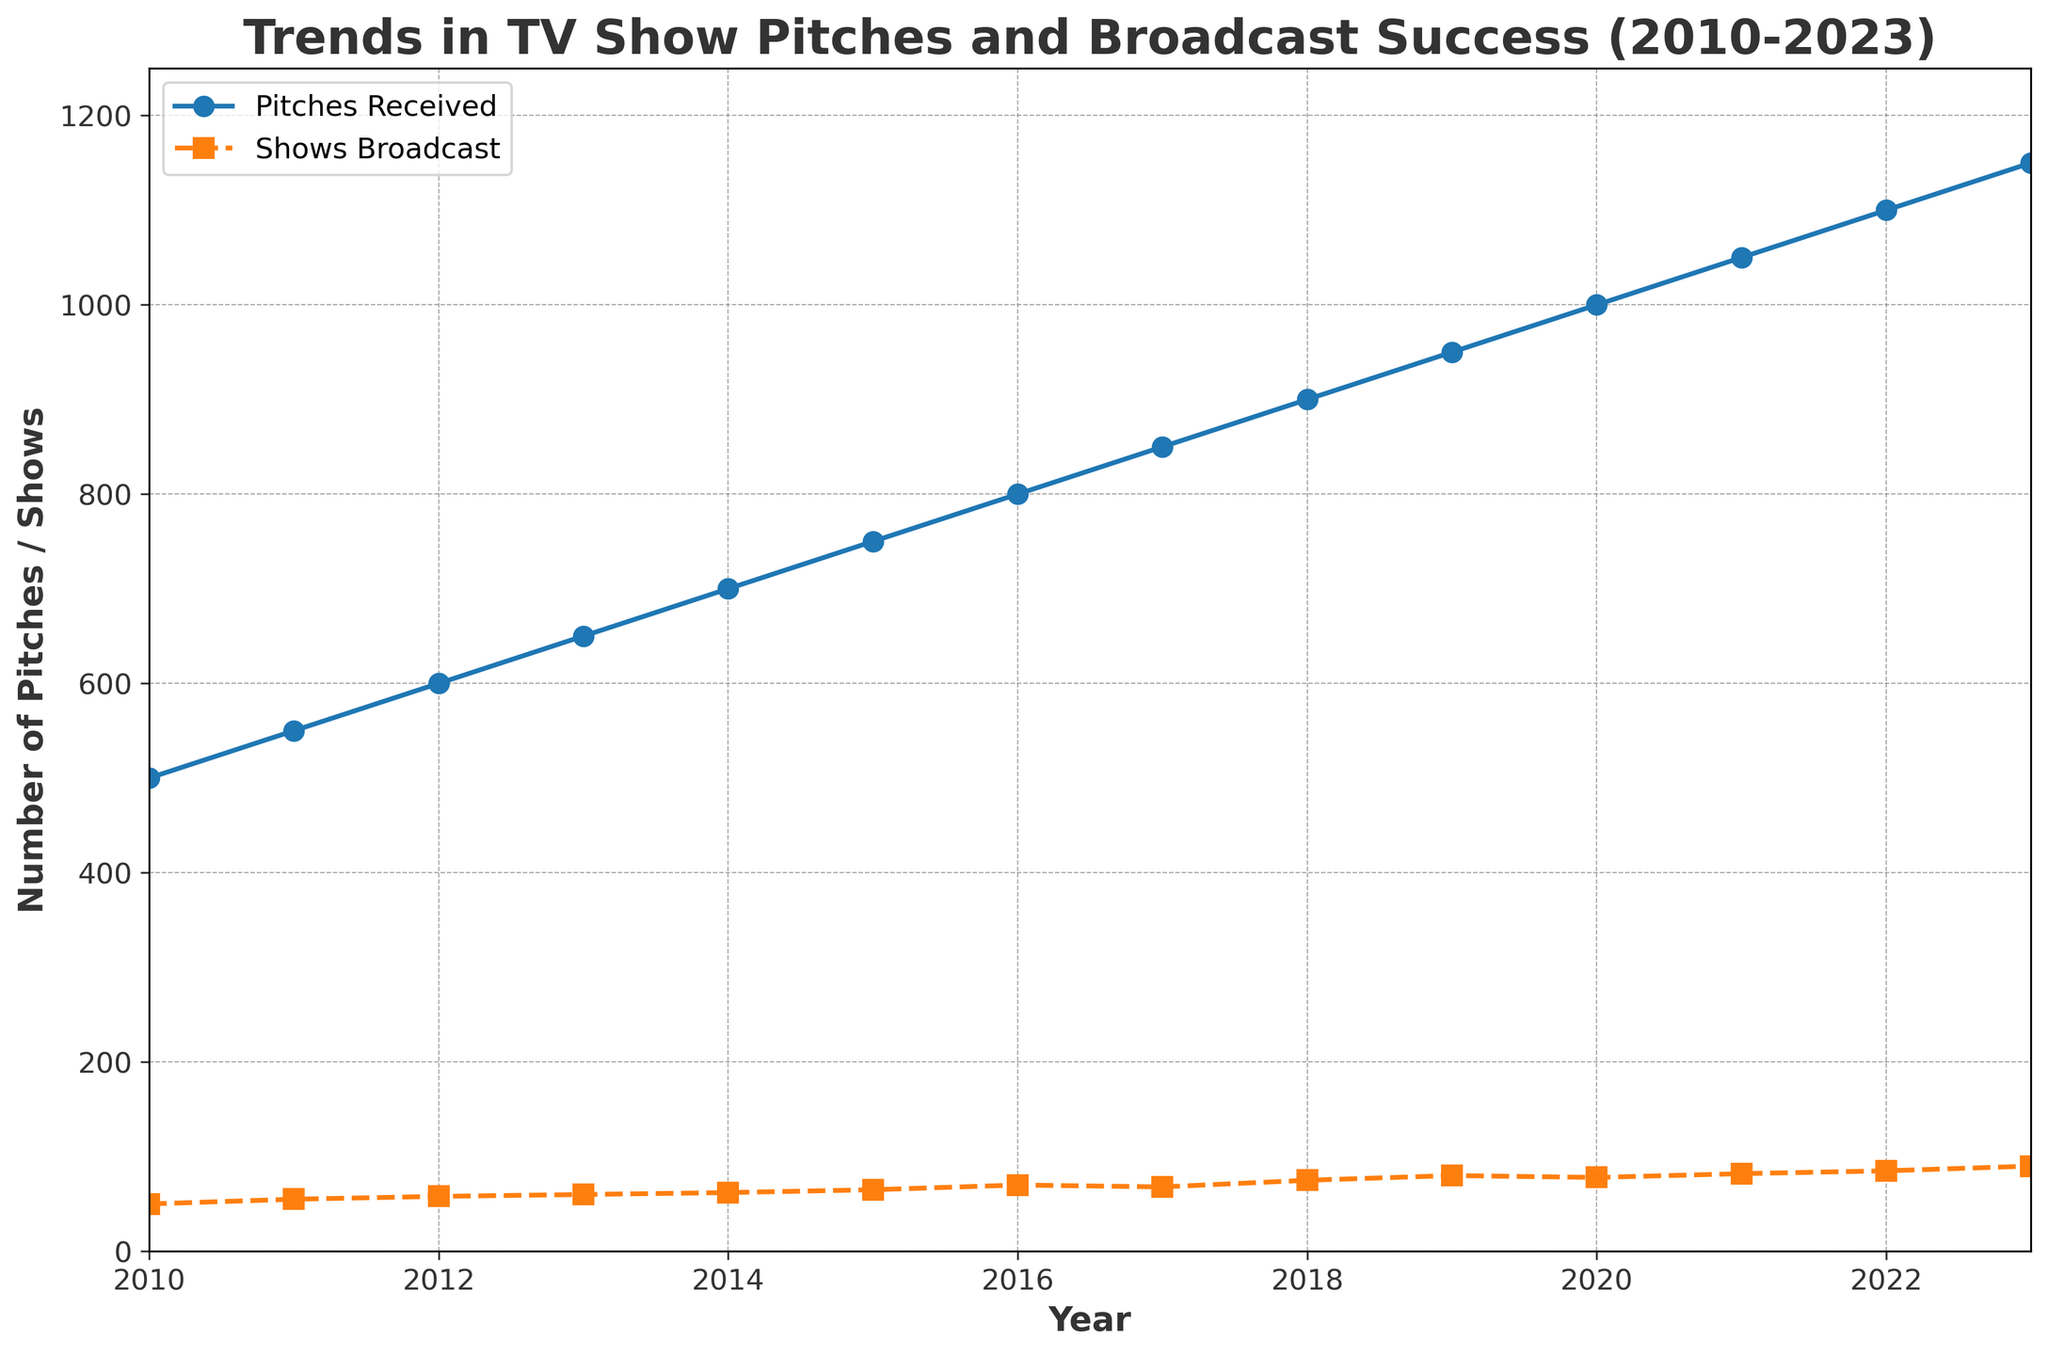- How many pitches were received in 2013, and how many of those made it to broadcast? In 2013, the number of pitches received can be visually identified from the plot. The 'Pitches Received' curve shows approximately 650 pitches, and the 'Shows Broadcast' curve shows around 60 shows.
Answer: 650 pitches, 60 shows - What is the trend in the number of TV show pitches received from 2010 to 2023? The figure shows an increasing trend in the number of TV show pitches received over the years. The line representing 'Pitches Received' consistently slopes upward from 2010 to 2023.
Answer: Increasing trend - By how much did the number of shows broadcast in 2016 differ from the number of shows broadcast in 2020? In 2016, the number of shows broadcast is approximately 70. In 2020, the number of shows broadcast is around 78. The difference is calculated as 78 - 70.
Answer: 8 - What is the average number of pitches received per year over the period of 2010-2023? The data points for 'Pitches Received' from 2010 to 2023 are 500, 550, 600, 650, 700, 750, 800, 850, 900, 950, 1000, 1050, 1100, and 1150. The average can be calculated by summing these values and dividing by the number of years (14). Sum: 11050 / 14.
Answer: 789.3 - Compare the success rate of TV show pitches making it to broadcast between 2012 and 2018. Which year had a higher success rate? For 2012, the success rate is calculated as (Shows Broadcast / Pitches Received) * 100 = (58 / 600) * 100 = 9.67%. For 2018, the success rate is (75 / 900) * 100 = 8.33%. Comparing these percentages shows 2012 has a higher success rate.
Answer: 2012 - Which year saw the smallest difference between the number of pitches received and the number of shows broadcast? By visually comparing the vertical gap between the 'Pitches Received' and 'Shows Broadcast' lines year by year, it appears the year with the smallest gap is 2013, where there are about 590 pitches received and 60 shows broadcast, resulting in a difference of 590 - 60.
Answer: 2013 - How did the number of shows broadcast change from 2019 to 2023? The plot shows that the number of shows broadcast increased from 80 in 2019 to 90 in 2023. The change can be calculated as 90 - 80.
Answer: Increase of 10 - What is the visual difference between the lines representing pitches received and shows broadcast? The 'Pitches Received' line is represented by a solid line with circular markers, while the 'Shows Broadcast' line is depicted with a dashed line and square markers.
Answer: Solid line with circles vs. dashed line with squares - Did the number of pitches received ever decrease between 2010 and 2023? By inspecting the trend of the 'Pitches Received' line on the plot, it consistently increases every year. There is no indication of any decrease during this period.
Answer: No - In which year did the number of pitches received reach 1000, and what was the number of shows broadcast that year? The plot indicates that the number of pitches received reached 1000 in the year 2020, and the number of shows broadcast in that year was approximately 78.
Answer: 2020, 78 